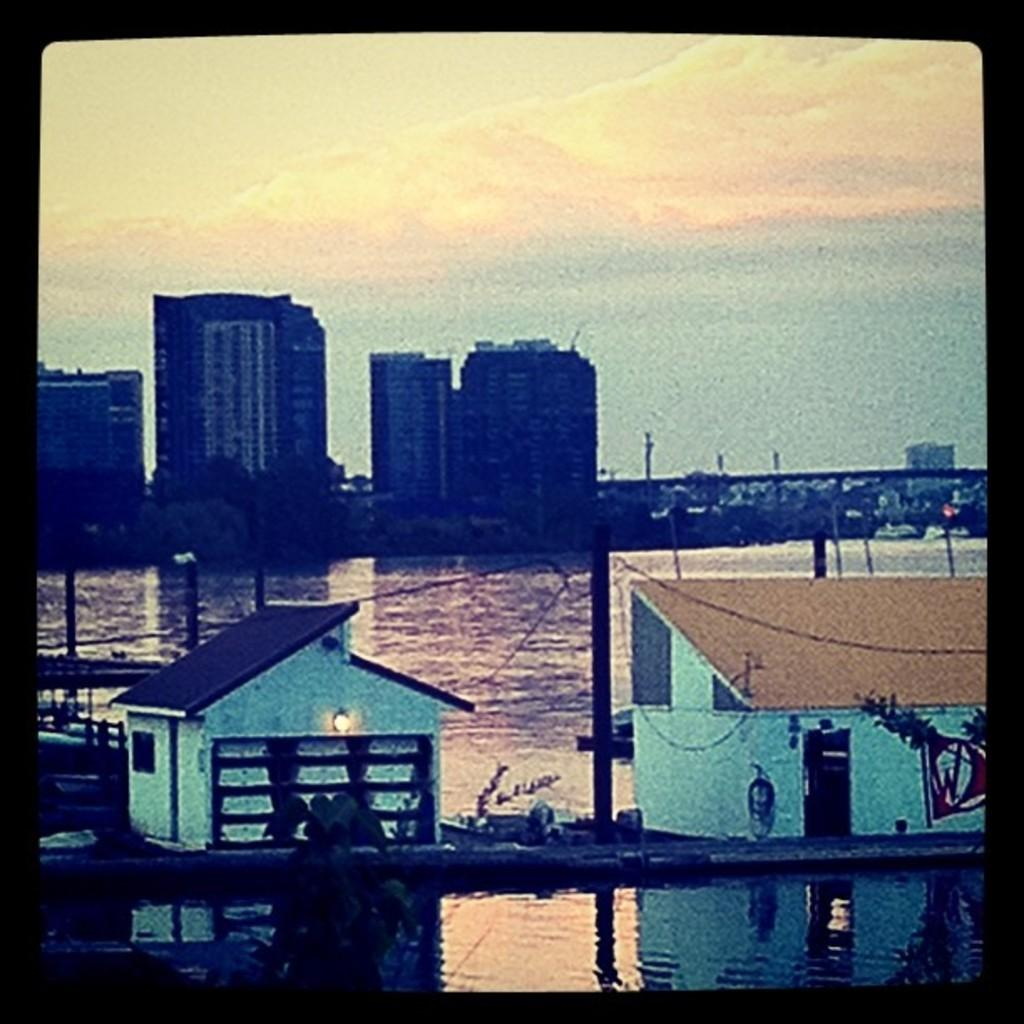What types of structures can be seen in the image? There are buildings and houses in the image. Can you describe the lighting conditions in the image? There is light visible in the image. What are the poles used for in the image? The purpose of the poles is not specified, but they are likely used for support or infrastructure. What natural element is visible in the image? Water is visible in the image. What part of the environment is visible in the image? The sky is visible in the image. How much rail is present in the image? There is no rail visible in the image. What type of part is missing from the buildings in the image? The image does not indicate any missing parts from the buildings. 